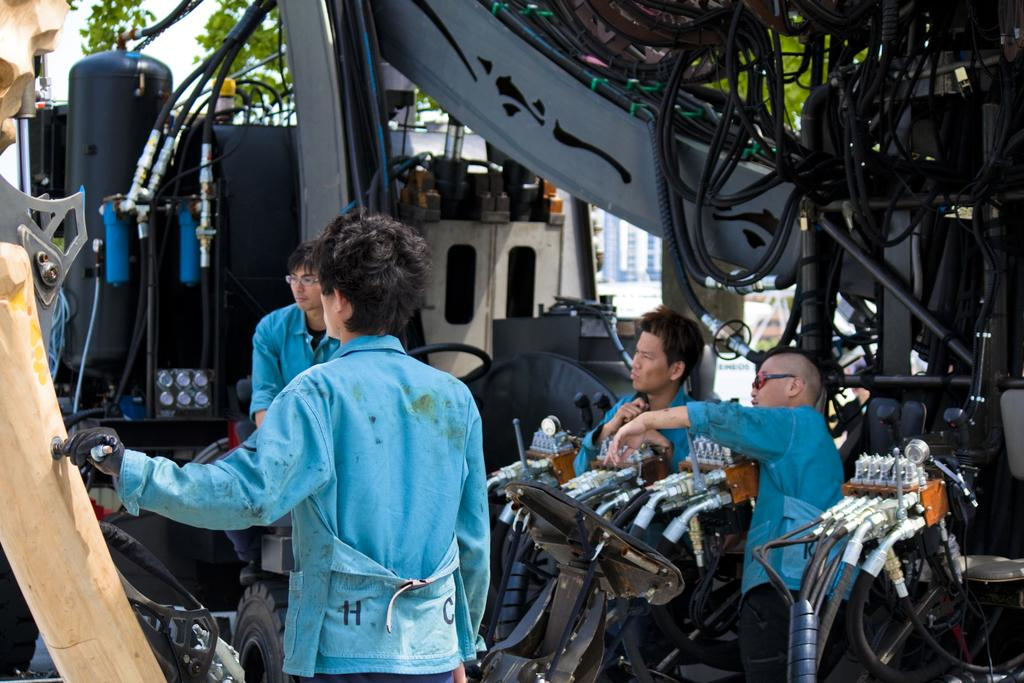How many people are in the image? There are four men in the image. What can be seen in front of the men? There are objects in front of the men. What is located on the right side of the image? There are cables on the right side of the image. What type of natural scenery is visible in the image? There are trees visible behind the objects. Where is the map located in the image? There is no map present in the image. Can you describe the monkey's behavior in the image? There is no monkey present in the image. 